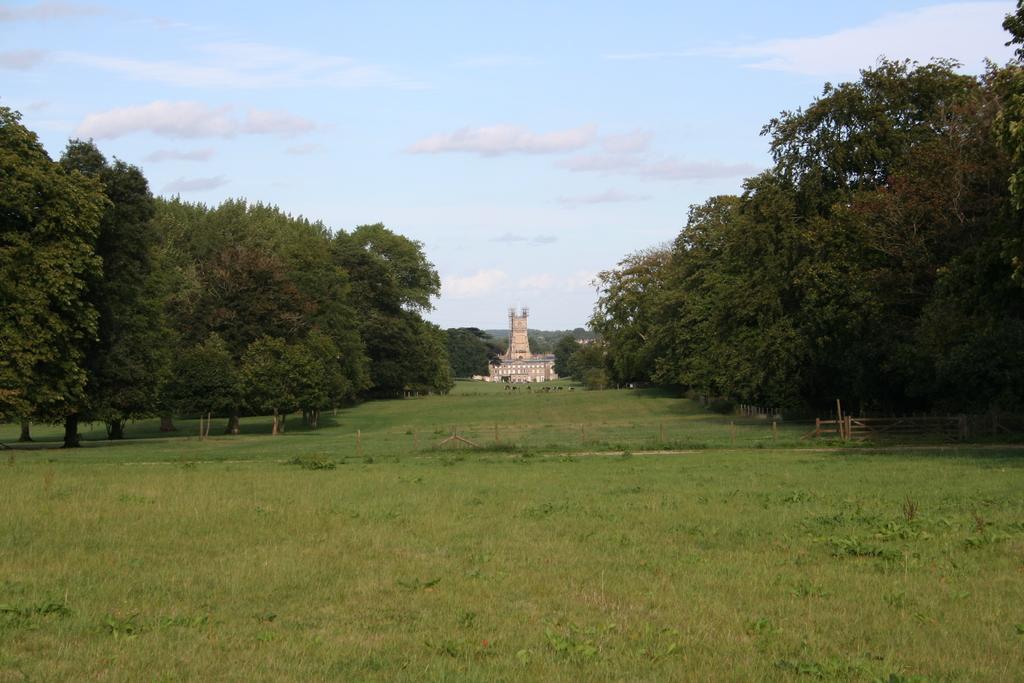What type of structure is visible in the image? There is a building in the image. What other natural elements can be seen in the image? There are trees and grass on the ground in the image. How would you describe the sky in the image? The sky is blue and cloudy in the image. How many turkeys are visible in the image? There are no turkeys present in the image. What type of clothing are the girls wearing in the image? There are no girls present in the image. 